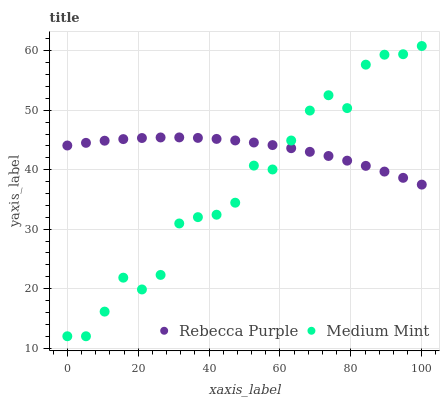Does Medium Mint have the minimum area under the curve?
Answer yes or no. Yes. Does Rebecca Purple have the maximum area under the curve?
Answer yes or no. Yes. Does Rebecca Purple have the minimum area under the curve?
Answer yes or no. No. Is Rebecca Purple the smoothest?
Answer yes or no. Yes. Is Medium Mint the roughest?
Answer yes or no. Yes. Is Rebecca Purple the roughest?
Answer yes or no. No. Does Medium Mint have the lowest value?
Answer yes or no. Yes. Does Rebecca Purple have the lowest value?
Answer yes or no. No. Does Medium Mint have the highest value?
Answer yes or no. Yes. Does Rebecca Purple have the highest value?
Answer yes or no. No. Does Rebecca Purple intersect Medium Mint?
Answer yes or no. Yes. Is Rebecca Purple less than Medium Mint?
Answer yes or no. No. Is Rebecca Purple greater than Medium Mint?
Answer yes or no. No. 